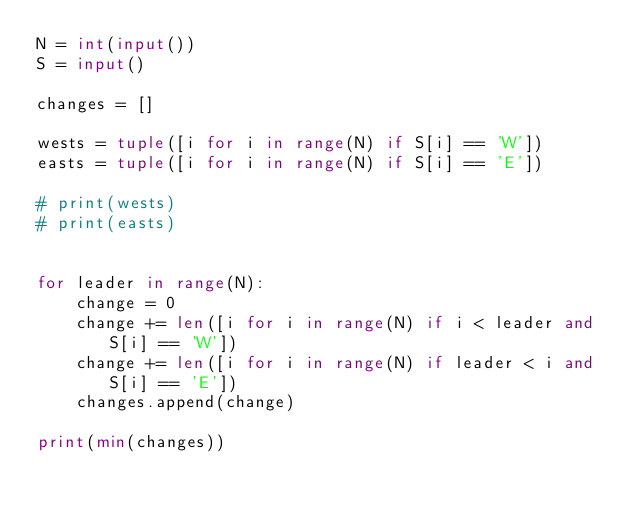Convert code to text. <code><loc_0><loc_0><loc_500><loc_500><_Python_>N = int(input())
S = input()

changes = []

wests = tuple([i for i in range(N) if S[i] == 'W'])
easts = tuple([i for i in range(N) if S[i] == 'E'])

# print(wests)
# print(easts)


for leader in range(N):
    change = 0
    change += len([i for i in range(N) if i < leader and S[i] == 'W'])
    change += len([i for i in range(N) if leader < i and S[i] == 'E'])
    changes.append(change)

print(min(changes))</code> 